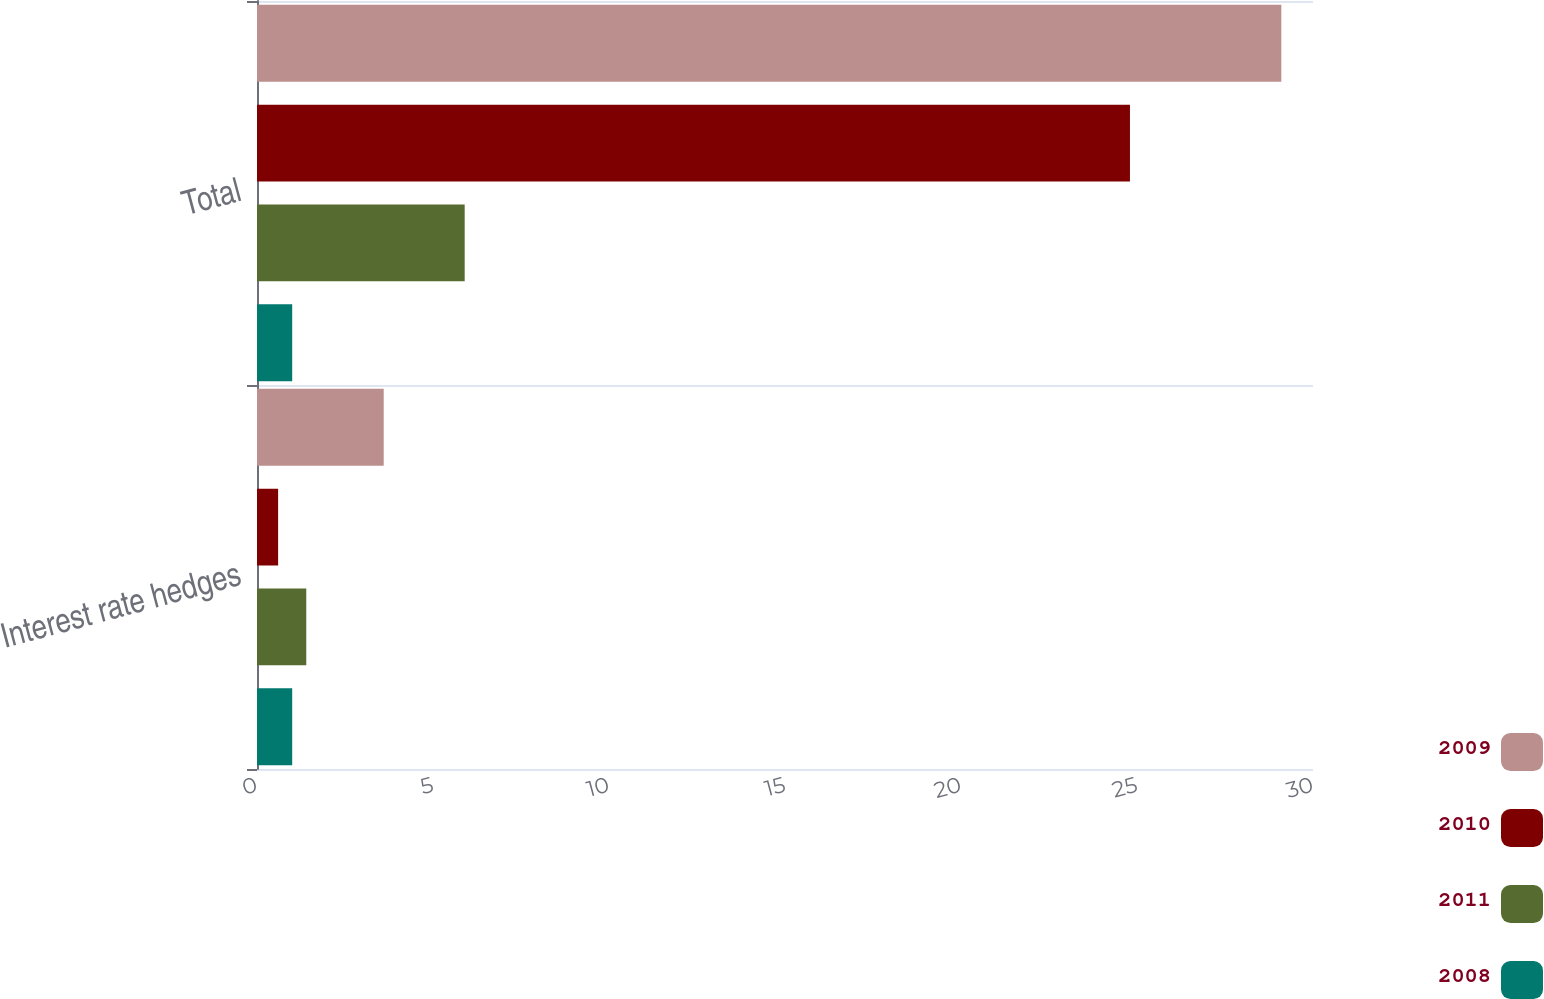Convert chart. <chart><loc_0><loc_0><loc_500><loc_500><stacked_bar_chart><ecel><fcel>Interest rate hedges<fcel>Total<nl><fcel>2009<fcel>3.6<fcel>29.1<nl><fcel>2010<fcel>0.6<fcel>24.8<nl><fcel>2011<fcel>1.4<fcel>5.9<nl><fcel>2008<fcel>1<fcel>1<nl></chart> 